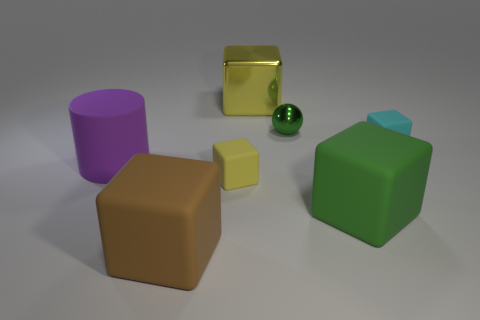What number of large things are made of the same material as the cyan cube?
Ensure brevity in your answer.  3. There is a ball that is made of the same material as the large yellow object; what color is it?
Your answer should be compact. Green. Do the rubber block that is behind the large purple matte cylinder and the tiny shiny thing have the same color?
Offer a terse response. No. There is a yellow object that is behind the green shiny thing; what is its material?
Provide a succinct answer. Metal. Is the number of brown cubes right of the large metallic block the same as the number of big green metal objects?
Your answer should be compact. Yes. How many big rubber things are the same color as the sphere?
Your response must be concise. 1. The other small object that is the same shape as the tiny yellow thing is what color?
Your answer should be very brief. Cyan. Does the yellow metallic object have the same size as the yellow rubber object?
Your answer should be compact. No. Is the number of tiny green shiny spheres on the right side of the green metal sphere the same as the number of rubber things behind the yellow metallic block?
Your response must be concise. Yes. Are there any big brown shiny spheres?
Make the answer very short. No. 